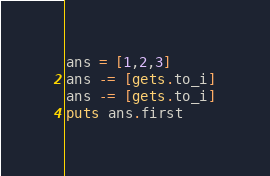Convert code to text. <code><loc_0><loc_0><loc_500><loc_500><_Ruby_>ans = [1,2,3]
ans -= [gets.to_i]
ans -= [gets.to_i]
puts ans.first</code> 